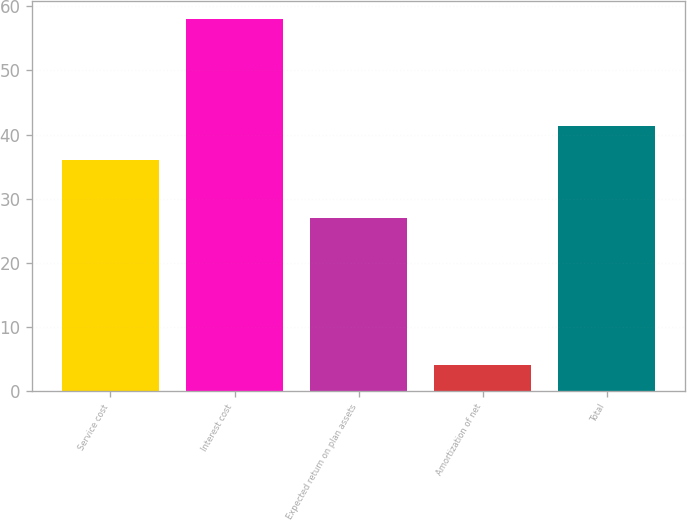Convert chart to OTSL. <chart><loc_0><loc_0><loc_500><loc_500><bar_chart><fcel>Service cost<fcel>Interest cost<fcel>Expected return on plan assets<fcel>Amortization of net<fcel>Total<nl><fcel>36<fcel>58<fcel>27<fcel>4<fcel>41.4<nl></chart> 